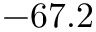<formula> <loc_0><loc_0><loc_500><loc_500>- 6 7 . 2</formula> 